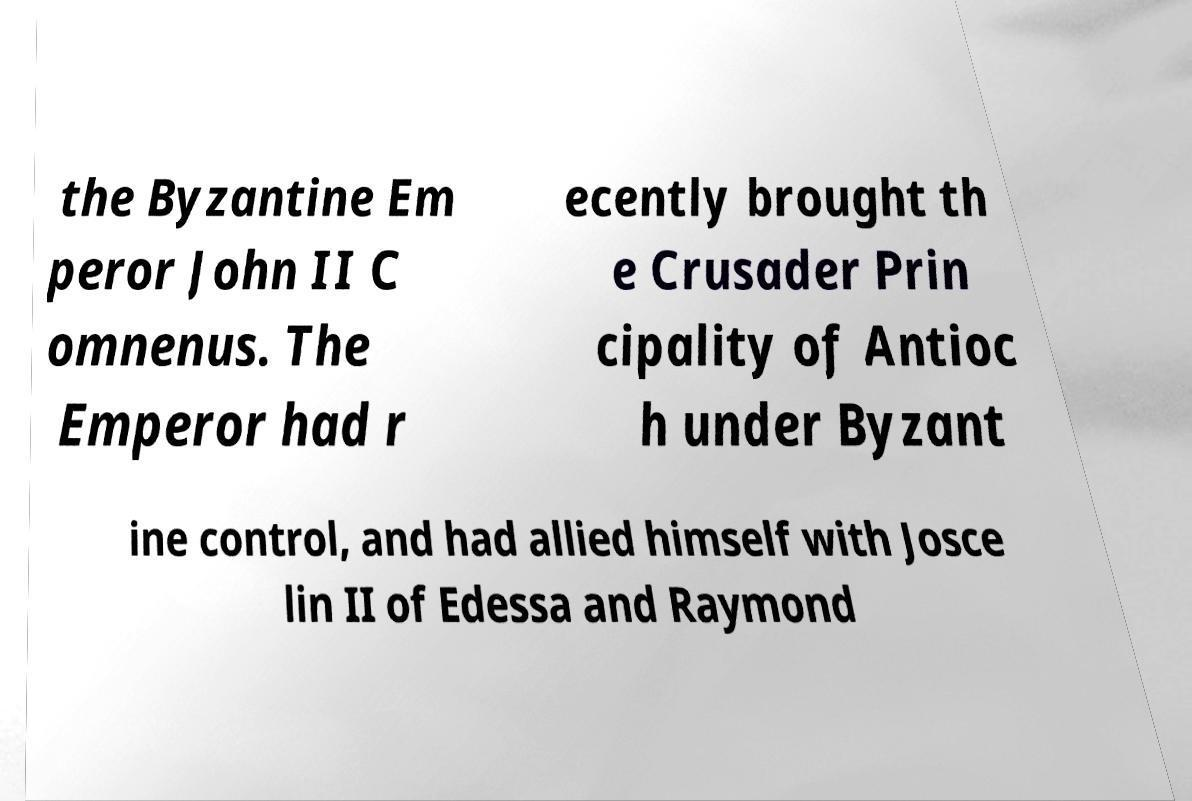There's text embedded in this image that I need extracted. Can you transcribe it verbatim? the Byzantine Em peror John II C omnenus. The Emperor had r ecently brought th e Crusader Prin cipality of Antioc h under Byzant ine control, and had allied himself with Josce lin II of Edessa and Raymond 